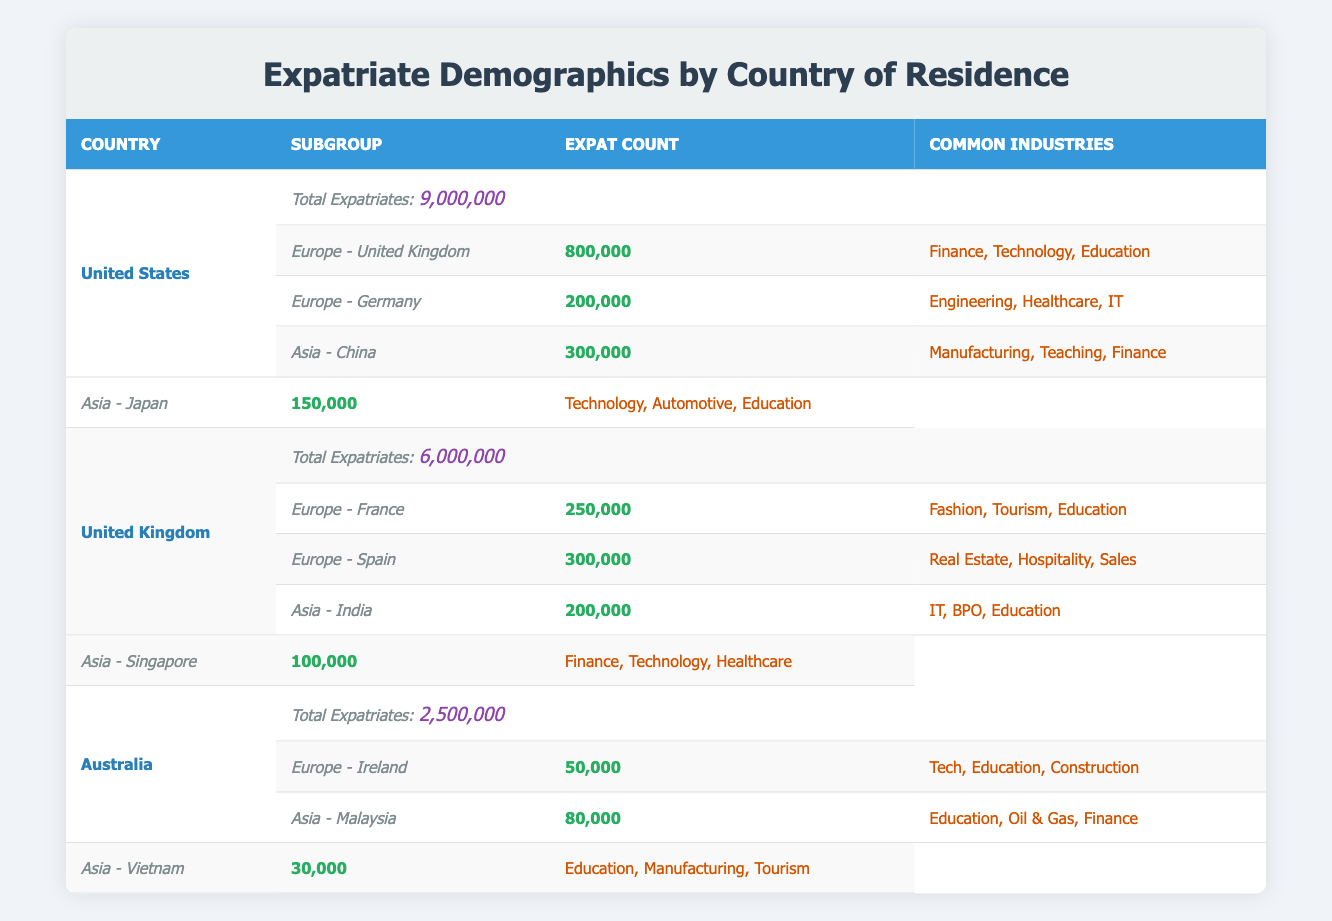What is the total number of expatriates from the United States? The total number of expatriates from the United States is displayed in the corresponding row under the category "Total Expatriates." It is explicitly given as 9,000,000.
Answer: 9,000,000 Which European country has the highest expatriate count from the United States? The European country with the highest expatriate count from the United States is the United Kingdom, which has an expatriate count of 800,000. This can be verified by comparing the expatriate counts listed for the countries under the European subgroup for the United States.
Answer: United Kingdom Is there an expatriate count from Australia to Vietnam? Yes, there is an expatriate count from Australia to Vietnam, which is listed as 30,000. This information is found in the corresponding row for Vietnam under the Asian subgroup for Australia.
Answer: Yes What is the total number of expatriates in the United Kingdom? The total number of expatriates in the United Kingdom is provided directly in the table under "Total Expatriates," which states it is 6,000,000.
Answer: 6,000,000 How many more expatriates does the United States have compared to Australia? To find how many more expatriates the United States has compared to Australia, subtract the total expatriate number of Australia (2,500,000) from that of the United States (9,000,000). Thus, 9,000,000 - 2,500,000 = 6,500,000.
Answer: 6,500,000 Which common industries are associated with expatriates from Germany? The common industries associated with expatriates from Germany are Engineering, Healthcare, and IT. This information can be found directly under the row for Germany in the subgroups of the United States.
Answer: Engineering, Healthcare, IT Does the United Kingdom have more expatriates in France or Spain? The United Kingdom has more expatriates in Spain (300,000) compared to France (250,000). This can be verified by examining the expatriate counts listed for both countries under the European subgroup for the United Kingdom.
Answer: Spain What percentage of the total expatriates from Australia are based in Malaysia? The expatriate count for Malaysia is 80,000. To find the percentage, divide this number by the total expatriates from Australia (2,500,000) and multiply by 100. Thus, (80,000 / 2,500,000) * 100 = 3.2%.
Answer: 3.2% What is the total number of expatriates from the United States living in Asia? The total number of expatriates from the United States living in Asia is the sum of the expatriate counts for China (300,000) and Japan (150,000). Hence, 300,000 + 150,000 = 450,000.
Answer: 450,000 